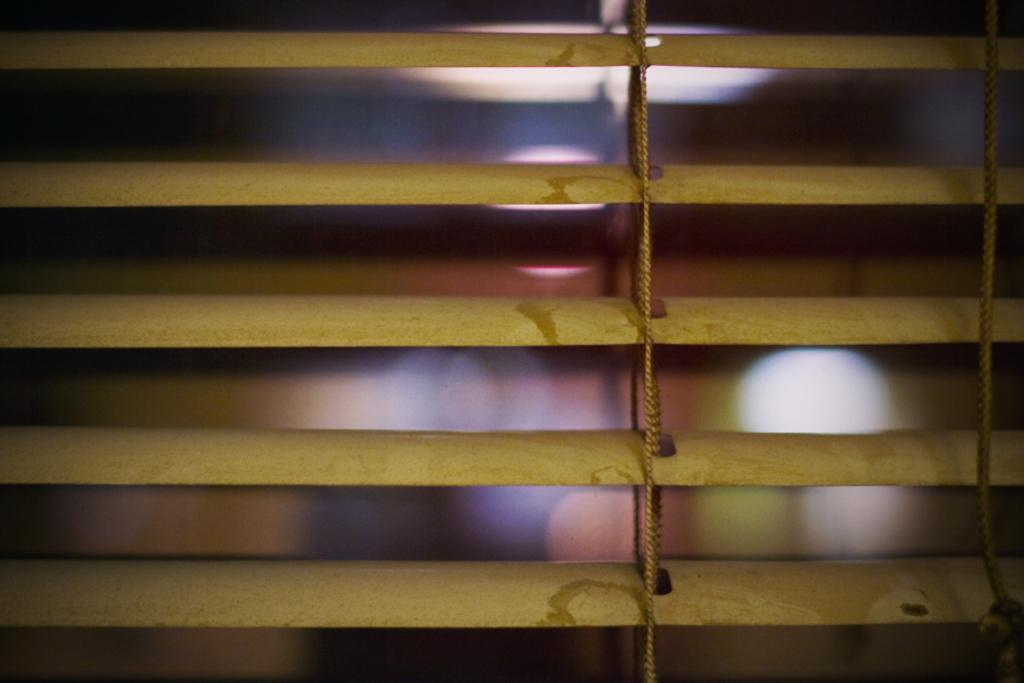Please provide a concise description of this image. In this image I can see few things and few ropes in the front. In the background I can see few lights and I can also see this image is little bit blurry. 